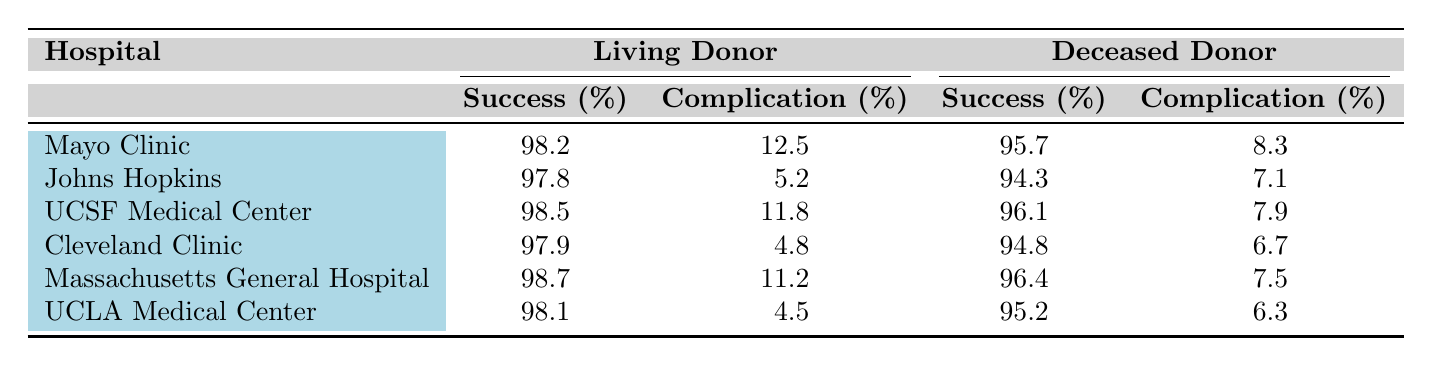What is the success rate of kidney transplants at Mayo Clinic for living donors? The table shows that the success rate for living donor transplants at Mayo Clinic is listed in the corresponding column, which is 98.2.
Answer: 98.2 Which hospital has the highest complication rate for living donor transplants? By looking at the complication rates for living donor transplants, Mayo Clinic's complication rate is 12.5%, which is higher than the other hospitals listed.
Answer: Mayo Clinic What is the average success rate for deceased donor transplants across all hospitals in 2020 and 2021? To find the average, add the success rates for deceased donor transplants: (95.7 + 94.3 + 96.1 + 94.8)/4 = 95.25. Therefore, to include the average for 2020 and 2021, sum the two years: (95.25 + 96.4 + 95.2)/3 = 95.39.
Answer: 95.39 Did UCSF Medical Center have a better success rate for living donor or deceased donor transplants in 2021? Comparing the two success rates, UCSF Medical Center has 98.5% for living donor transplants and 96.1% for deceased donor transplants. Therefore, living donor transplants had a higher success rate.
Answer: Yes What is the difference in complication rates between living donor and deceased donor transplants at Johns Hopkins in 2020? The complication rates for Johns Hopkins are 5.2% for living donors and 7.1% for deceased donors. The difference is calculated as 7.1 - 5.2 = 1.9%.
Answer: 1.9% 